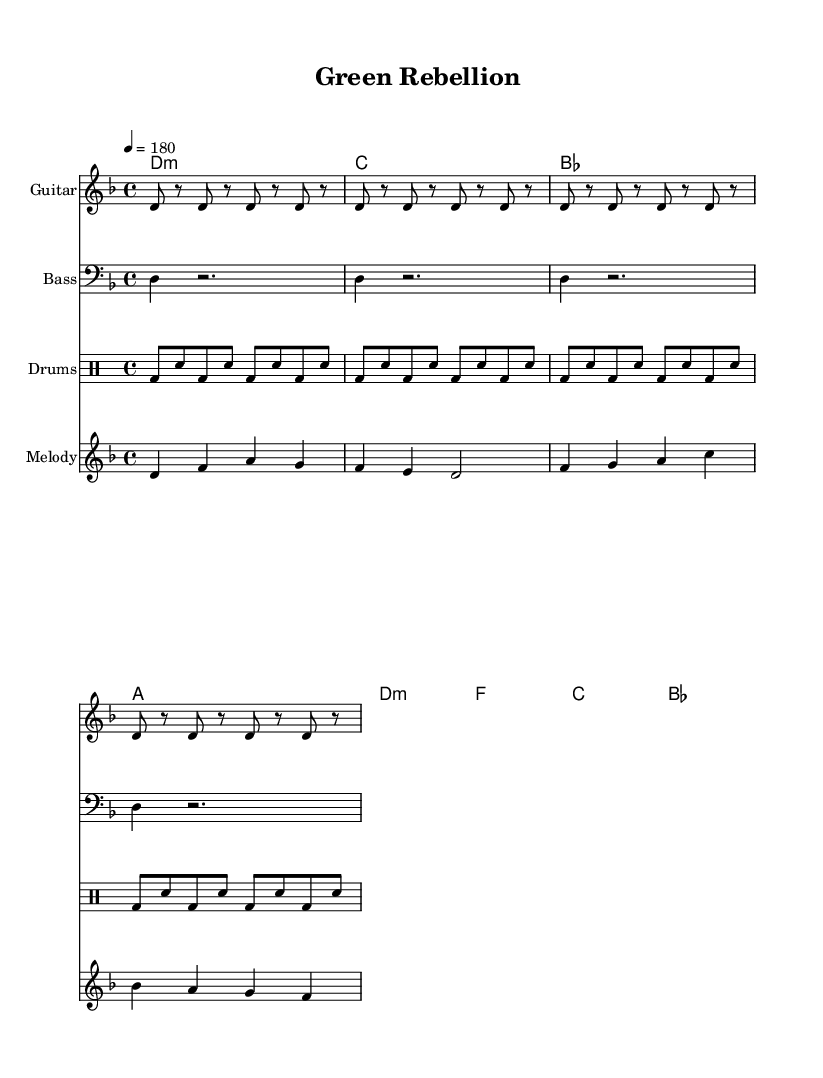What is the key signature of this music? The key signature is indicated at the beginning of the sheet music and is D minor, which has one flat (B flat).
Answer: D minor What is the time signature of this music? The time signature is shown after the key signature and is 4/4, meaning there are four beats per measure.
Answer: 4/4 What is the tempo of the music? The tempo is indicated by "4 = 180" at the beginning, which specifies that the quarter note gets 180 beats per minute.
Answer: 180 What type of chords are primarily used in the verse section? The verse chords include D minor, C major, B flat, and A major, which are common in punk music for their straightforward harmonic structure.
Answer: D minor How many measures are there in the verse? The melody section for the verse shows two measures of music, which are indicated by the separation of the notes and rests in the melodic line.
Answer: 2 What is the main theme of the lyrics? The lyrics talk about fighting against forest destruction and advocating for plant conservation, aligned with the themes often found in hardcore punk.
Answer: Fighting deforestation What is the significant call to action in the chorus? The chorus explicitly states "Stand up, fight back, save the trees," urging listeners to take action in a confrontational and rebellious manner.
Answer: Save the trees 